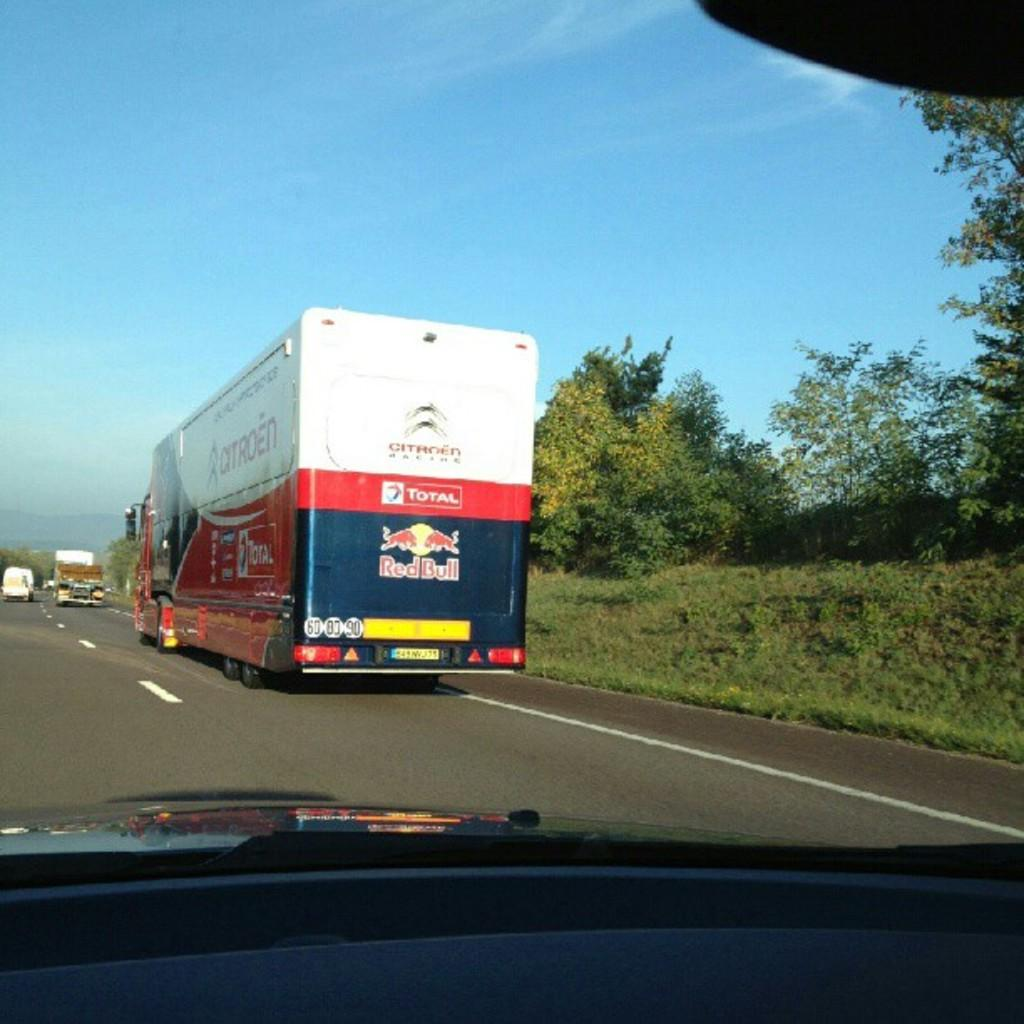What types of objects can be seen in the image? There are vehicles in the image. What can be seen beneath the vehicles? The ground is visible in the image. What type of vegetation is present in the image? There is grass, plants, and trees in the image. What is visible above the vehicles and vegetation? The sky is visible in the image. Where is the tray located in the image? There is no tray present in the image. What type of bed can be seen in the image? There is no bed present in the image. 